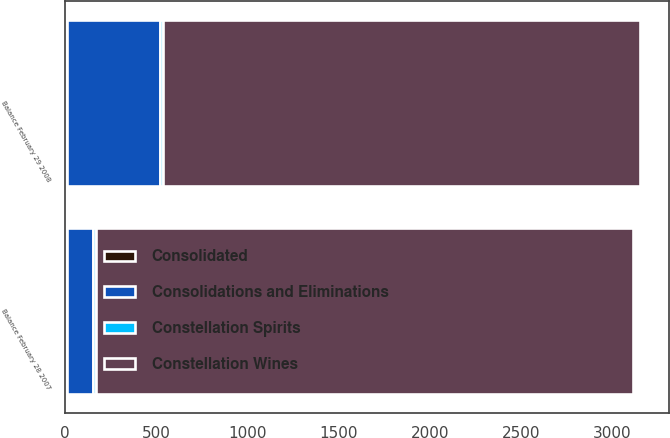<chart> <loc_0><loc_0><loc_500><loc_500><stacked_bar_chart><ecel><fcel>Balance February 28 2007<fcel>Balance February 29 2008<nl><fcel>Constellation Wines<fcel>2939.5<fcel>2614.1<nl><fcel>Consolidations and Eliminations<fcel>144.4<fcel>509.8<nl><fcel>Constellation Spirits<fcel>13<fcel>13<nl><fcel>Consolidated<fcel>13<fcel>13<nl></chart> 